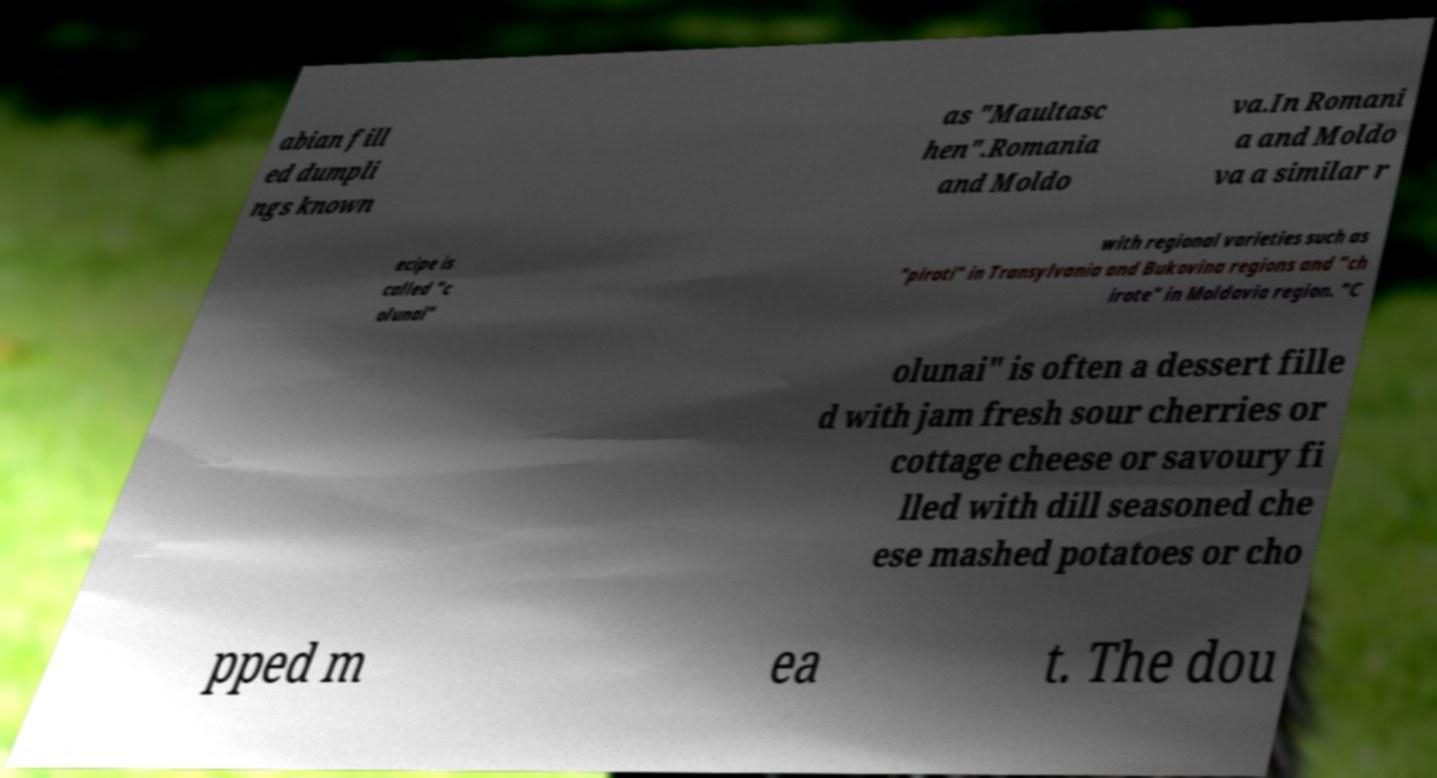Could you extract and type out the text from this image? abian fill ed dumpli ngs known as "Maultasc hen".Romania and Moldo va.In Romani a and Moldo va a similar r ecipe is called "c olunai" with regional varieties such as "piroti" in Transylvania and Bukovina regions and "ch irote" in Moldavia region. "C olunai" is often a dessert fille d with jam fresh sour cherries or cottage cheese or savoury fi lled with dill seasoned che ese mashed potatoes or cho pped m ea t. The dou 